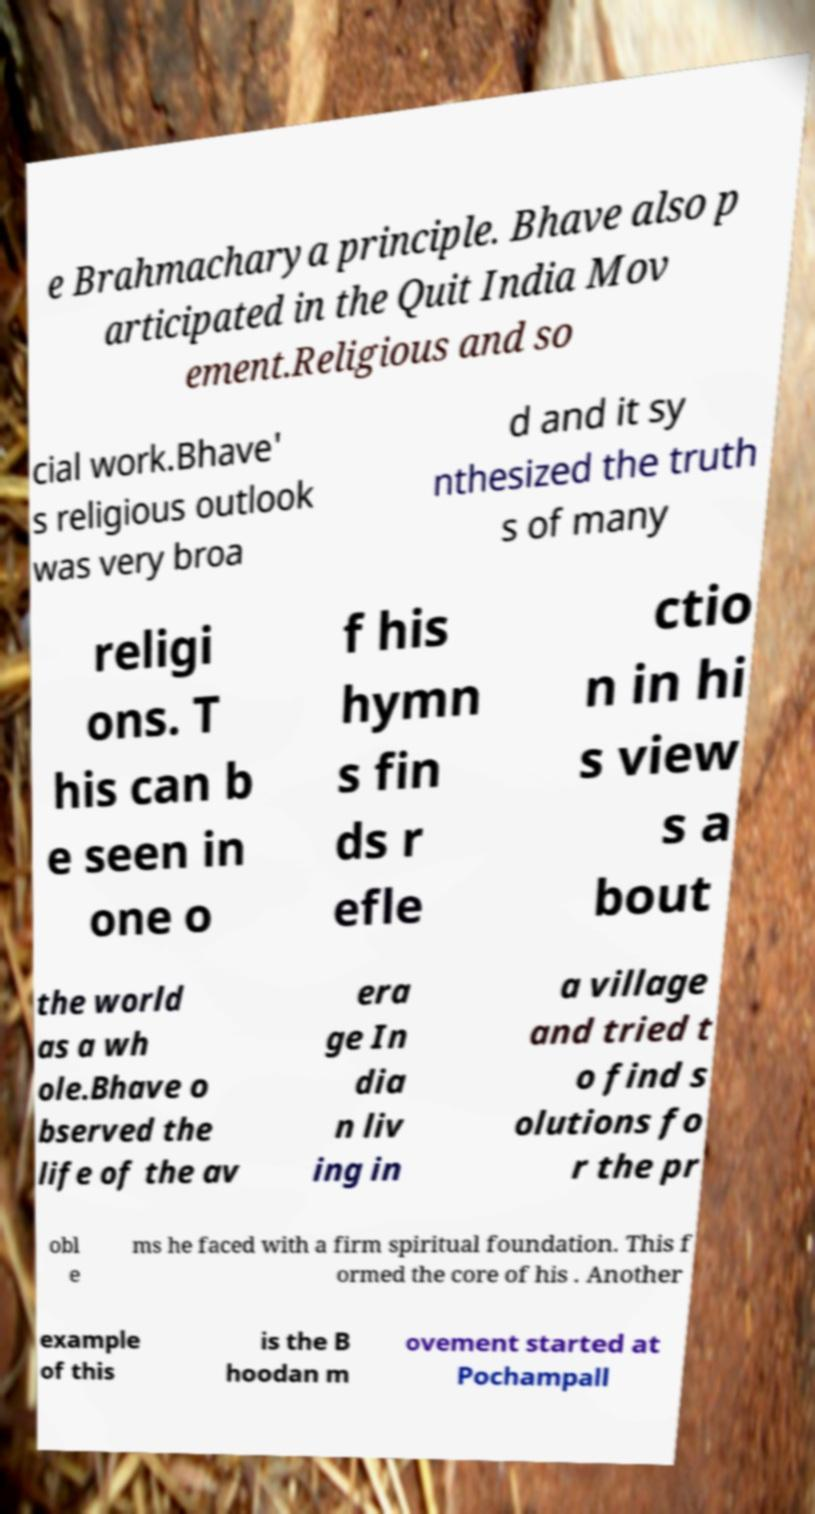Can you read and provide the text displayed in the image?This photo seems to have some interesting text. Can you extract and type it out for me? e Brahmacharya principle. Bhave also p articipated in the Quit India Mov ement.Religious and so cial work.Bhave' s religious outlook was very broa d and it sy nthesized the truth s of many religi ons. T his can b e seen in one o f his hymn s fin ds r efle ctio n in hi s view s a bout the world as a wh ole.Bhave o bserved the life of the av era ge In dia n liv ing in a village and tried t o find s olutions fo r the pr obl e ms he faced with a firm spiritual foundation. This f ormed the core of his . Another example of this is the B hoodan m ovement started at Pochampall 